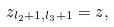<formula> <loc_0><loc_0><loc_500><loc_500>z _ { l _ { 2 } + 1 , l _ { 3 } + 1 } = z ,</formula> 